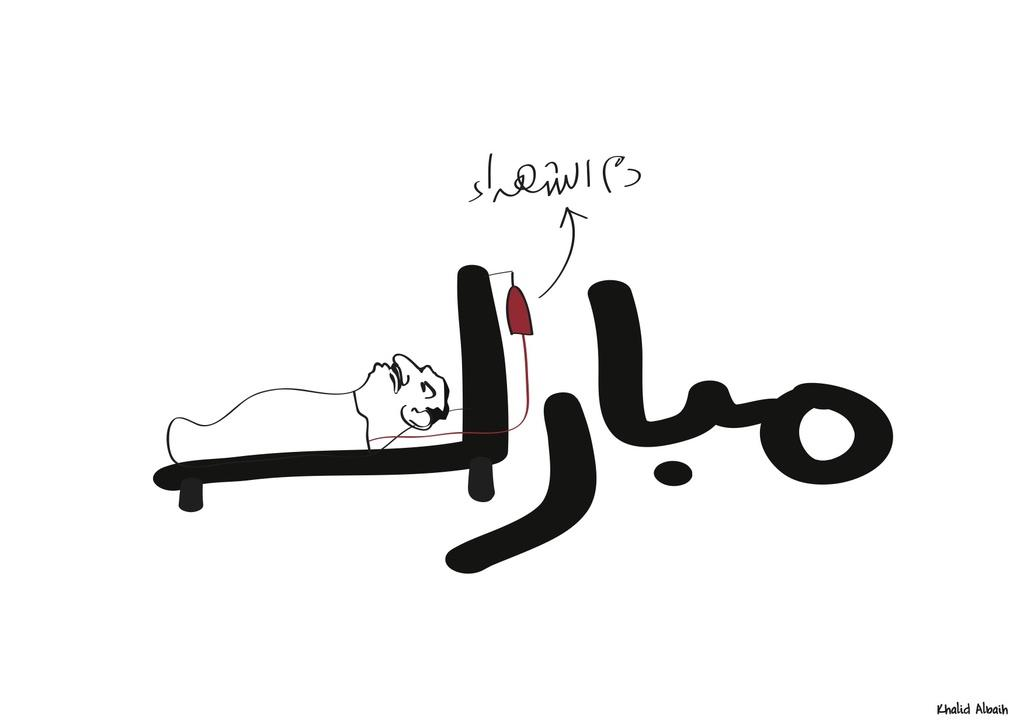What is the color of the poster in the image? The poster in the image is white. What can be found on the white poster? Something is written on the poster, and there is a cartoon person depicted on it. Where is the watermark located in the image? The watermark is in the bottom right corner of the image. Can you tell me how the cartoon person is flying in the image? The cartoon person is not flying in the image; they are depicted on the poster as a static image. 